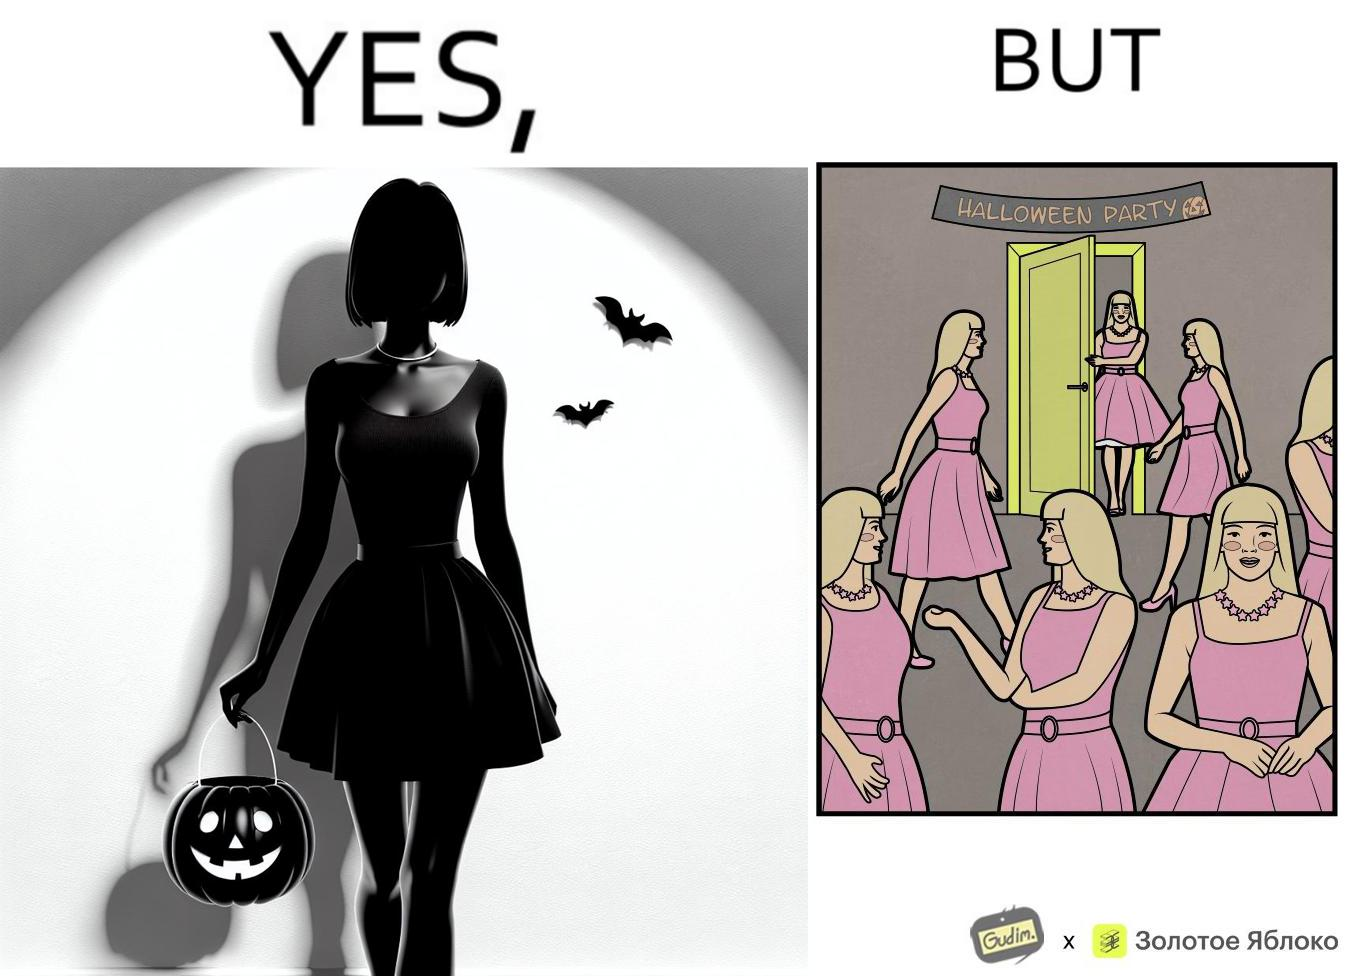Describe what you see in the left and right parts of this image. In the left part of the image: A woman entering a Halloween Party wearing a pink top and skirt with a necklace around the neck as costume. In the right part of the image: A person entering a Halloween Party wearing a pink top and skirt along with a necklace around the neck as costume, and others in the room have the same costume. 